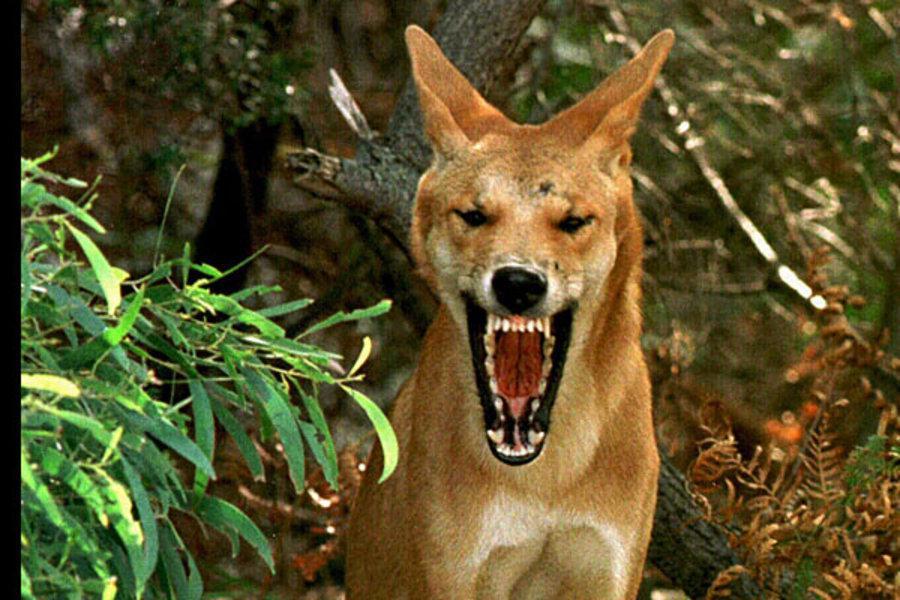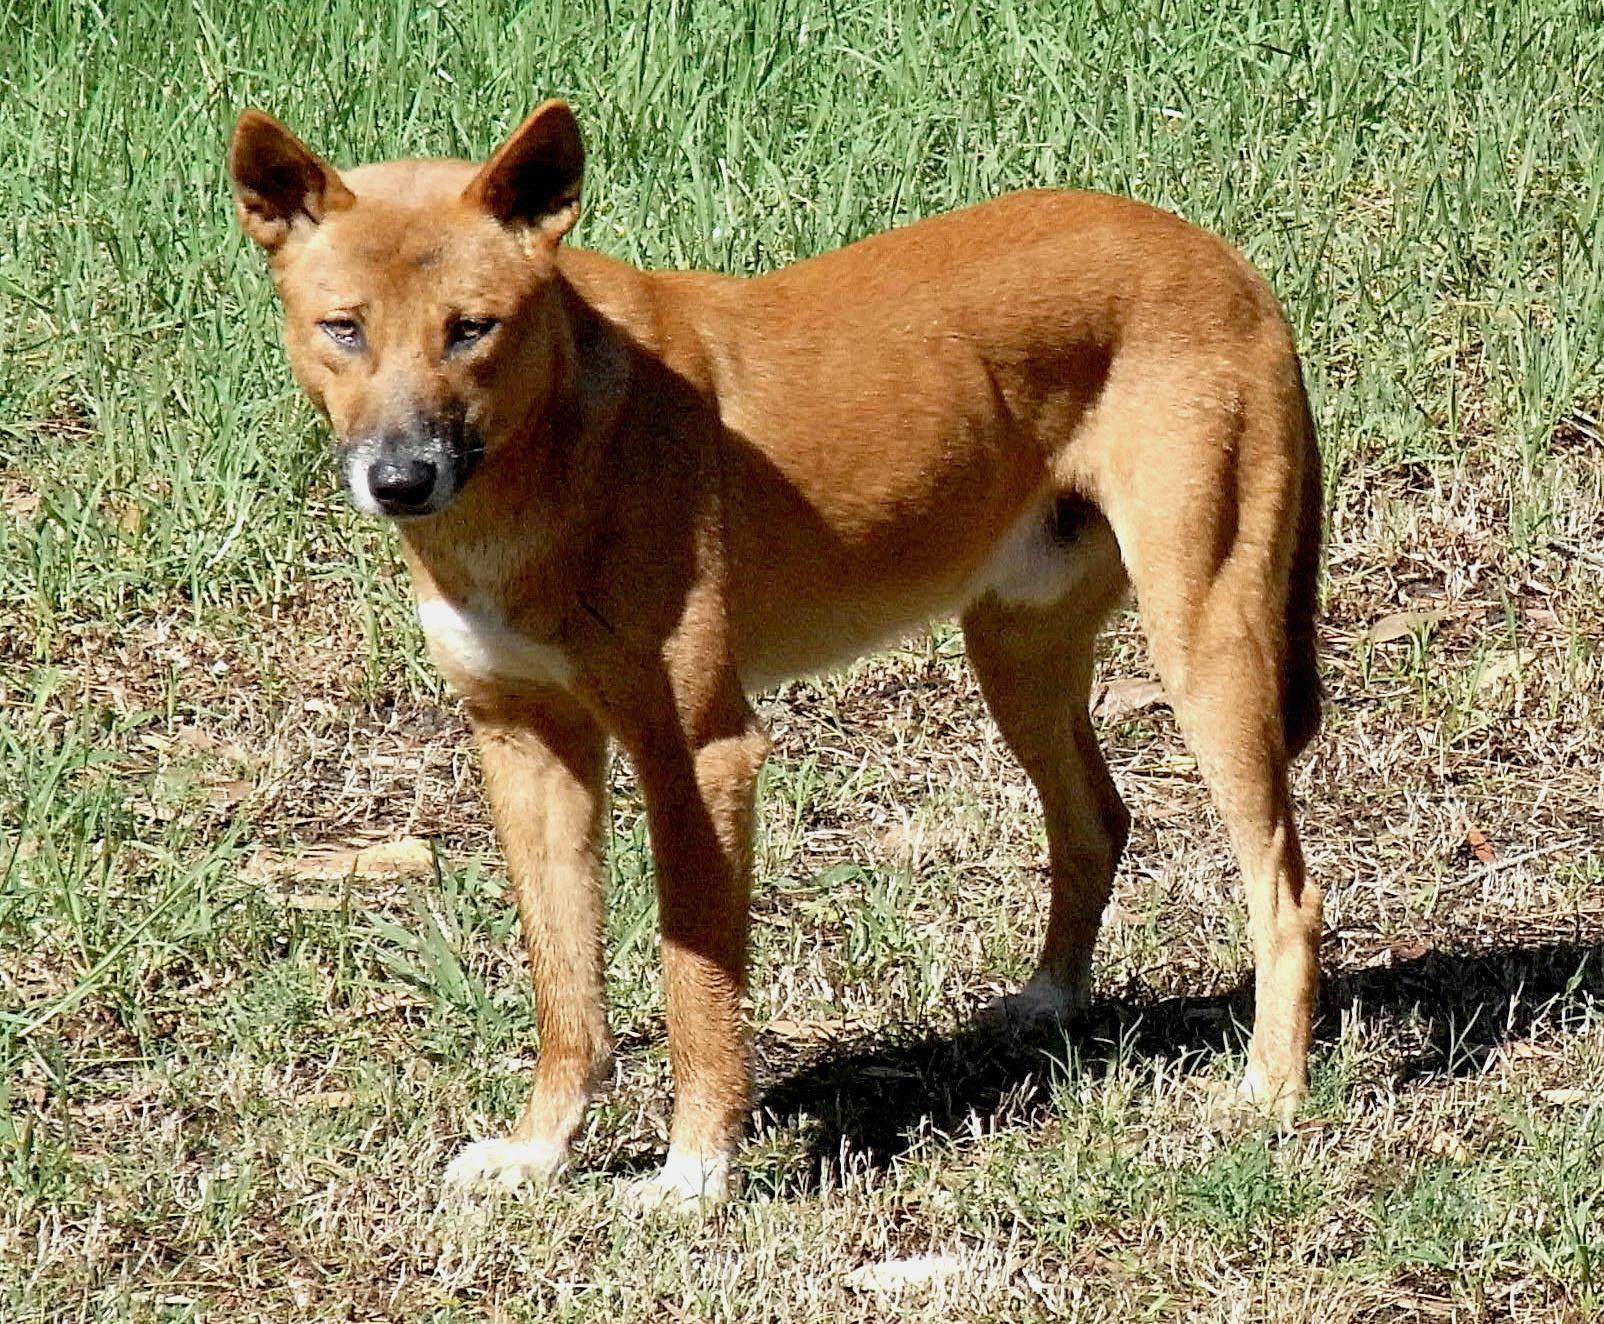The first image is the image on the left, the second image is the image on the right. Evaluate the accuracy of this statement regarding the images: "Two wild dogs are lying outside in the image on the left.". Is it true? Answer yes or no. No. The first image is the image on the left, the second image is the image on the right. Analyze the images presented: Is the assertion "Two orange dogs are reclining in similar positions near one another." valid? Answer yes or no. No. 